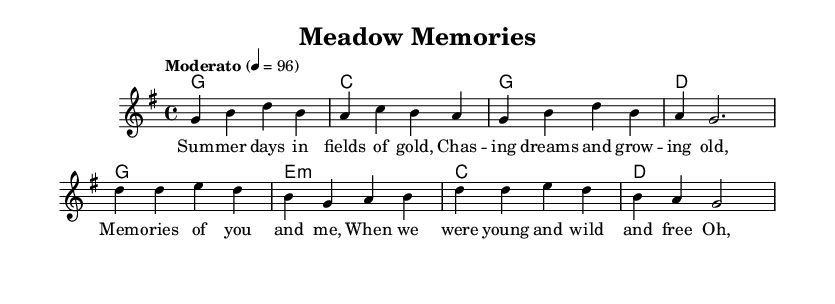What is the key signature of this music? The key signature is G major, which has one sharp: F#. This is indicated at the beginning of the staff.
Answer: G major What is the time signature of this music? The time signature is 4/4, which means there are four beats in each measure and a quarter note gets one beat. This is shown at the beginning of the staff.
Answer: 4/4 What is the tempo marking for this piece? The tempo marking indicates "Moderato" with a speed of 96 beats per minute, which defines the overall tempo of the song. This is listed at the top of the sheet music.
Answer: Moderato 4 = 96 How many measures are in the verse section? The verse consists of 4 measures, identified by counting the segments of the melody where the music is divided. Each line of the melody is structured into measures.
Answer: 4 What is the last chord of the chorus? The last chord in the chorus is D major, which is noted at the end of the chord progression. This can be found by examining the final chords beneath the melody.
Answer: D What themes are reflected in the lyrics of this piece? The lyrics reflect themes of nostalgia and childhood memories, as they describe experiences and feelings of youth and freedom. This is derived from analyzing the words and the emotional tone conveyed.
Answer: Nostalgia, childhood What kind of musical structure does this piece have? The piece has a verse-chorus structure, where the verse introduces the theme and the chorus reinforces it, a common characteristic in folk songs. This is evident from the layout of lyrics and indication by separate sections.
Answer: Verse-chorus 